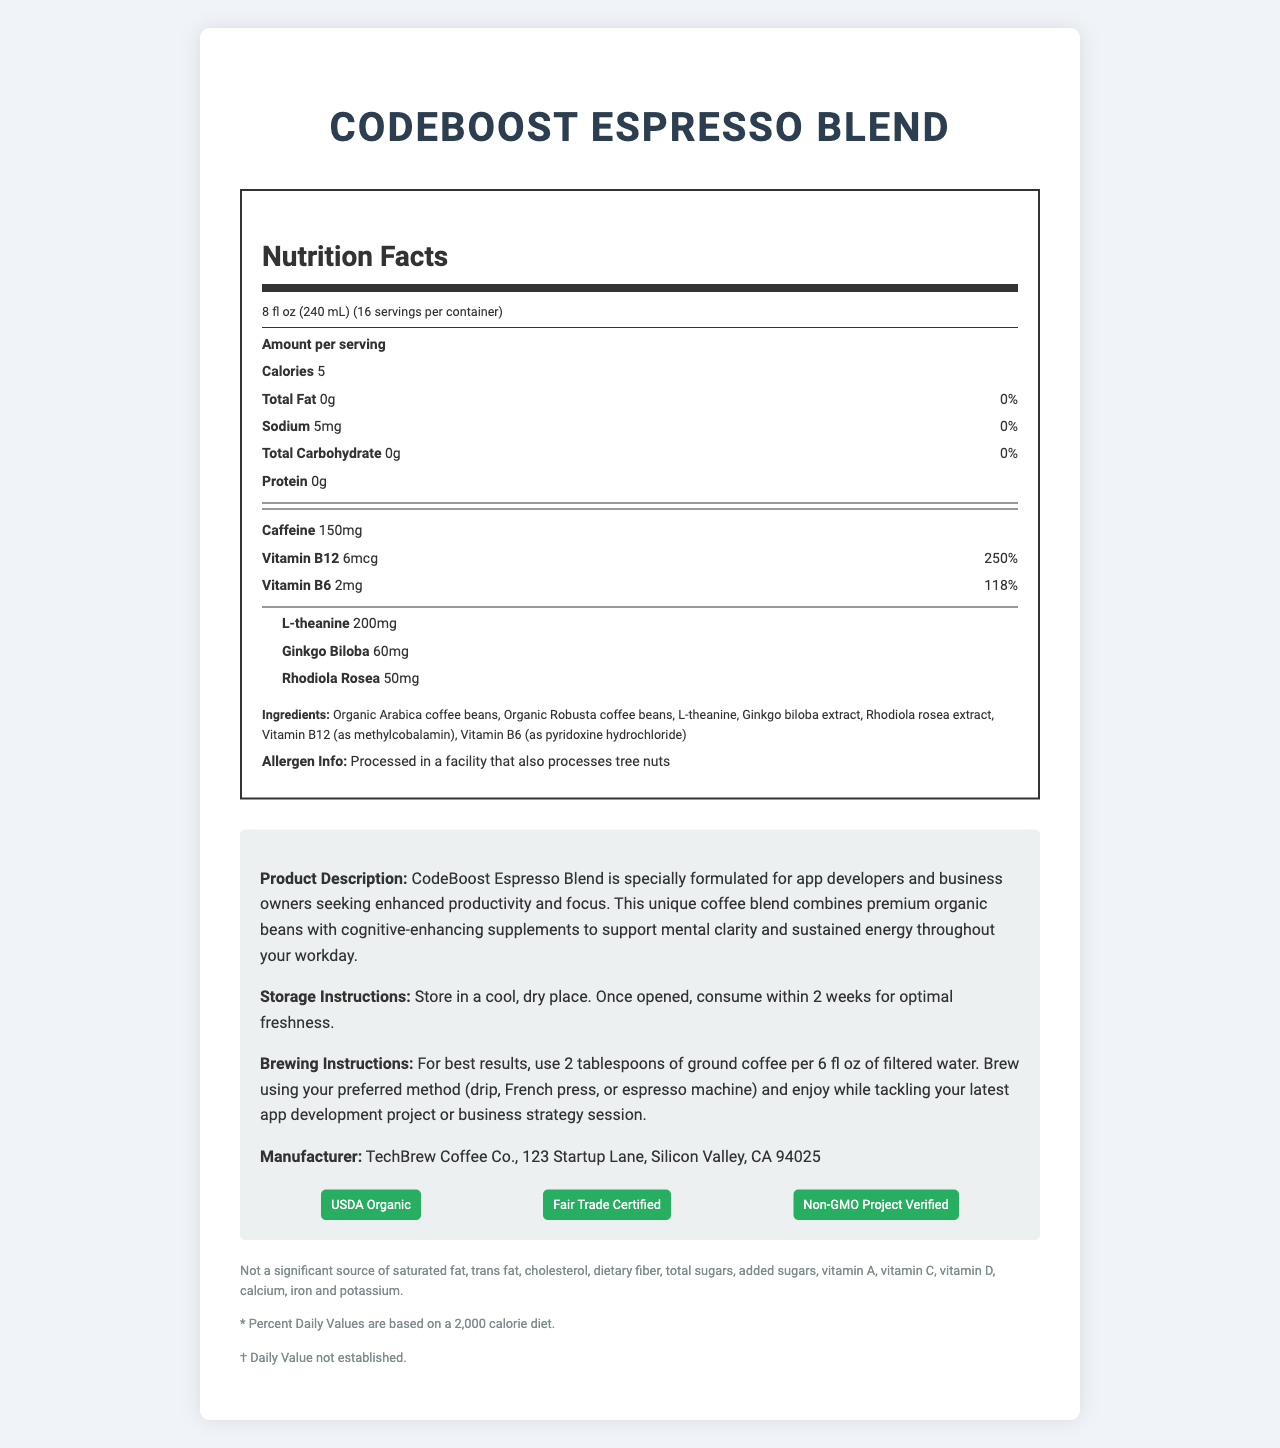what is the serving size for CodeBoost Espresso Blend? The serving size is mentioned at the top of the nutrition label as "8 fl oz (240 mL)".
Answer: 8 fl oz (240 mL) how many servings are there per container of CodeBoost Espresso Blend? The number of servings per container is listed as "16" in the serving information section of the document.
Answer: 16 how many calories are in one serving of CodeBoost Espresso Blend? The number of calories per serving is clearly stated as "Calories 5" in the nutrition label.
Answer: 5 how much caffeine does one serving of CodeBoost Espresso Blend contain? The amount of caffeine per serving is listed in the vitamins section as "Caffeine 150mg".
Answer: 150mg what are the main ingredients of CodeBoost Espresso Blend? The main ingredients are listed in the ingredients section of the document.
Answer: Organic Arabica coffee beans, Organic Robusta coffee beans, L-theanine, Ginkgo biloba extract, Rhodiola rosea extract, Vitamin B12 (as methylcobalamin), Vitamin B6 (as pyridoxine hydrochloride) which vitamin in CodeBoost Espresso Blend has the highest daily value percentage? Vitamin B12 has a daily value of 250%, which is the highest compared to other vitamins listed.
Answer: Vitamin B12 in which type of facility is CodeBoost Espresso Blend processed? A. Gluten-free B. Gluten and dairy-free C. Tree nut processing facility D. Dairy-free The allergen info states that the product is "Processed in a facility that also processes tree nuts".
Answer: C. Tree nut processing facility how should you store CodeBoost Espresso Blend once opened? A. In the refrigerator B. In a cool, dry place C. In a humid place D. In an airtight container The storage instructions specify to "Store in a cool, dry place."
Answer: B. In a cool, dry place how many tablespoons of ground coffee should you use per 6 fl oz of filtered water? The brewing instructions recommend using "2 tablespoons of ground coffee per 6 fl oz of filtered water."
Answer: 2 tablespoons does CodeBoost Espresso Blend contain any significant amount of dietary fiber or total sugars? The disclaimers state that it is not a significant source of dietary fiber, total sugars, among other nutrients.
Answer: No is CodeBoost Espresso Blend non-GMO certified? One of the certifications listed is "Non-GMO Project Verified."
Answer: Yes what is the primary purpose of CodeBoost Espresso Blend described in the product description? The product description mentions that the blend is formulated for "enhanced productivity and focus."
Answer: Enhanced productivity and focus list all certifications that CodeBoost Espresso Blend holds. The certifications section lists these three certifications.
Answer: USDA Organic, Fair Trade Certified, Non-GMO Project Verified does CodeBoost Espresso Blend have any cholesterol or saturated fat? The disclaimers mention that it is not a significant source of cholesterol or saturated fat.
Answer: No how long should you consume CodeBoost Espresso Blend after opening for optimal freshness? The storage instructions state that once opened, it should be consumed within 2 weeks for optimal freshness.
Answer: Within 2 weeks describe the main idea of the document. The entire document outlines the features and benefits of CodeBoost Espresso Blend. It includes serving size, nutritional values, ingredients, storage and brewing instructions, allergen and certification information, and a product description geared towards productivity and focus enhancement.
Answer: The document provides nutritional and product information about CodeBoost Espresso Blend, which is a specialty coffee designed to boost productivity and focus. It details the ingredients, nutritional content, certifications, and usage instructions. how does CodeBoost Espresso Blend enhance mental clarity and sustained energy? The document mentions that the blend supports mental clarity and sustained energy but does not provide specific details or studies explaining how it achieves this.
Answer: Not enough information does CodeBoost Espresso Blend contain any Vitamin D? The disclaimers section explicitly mentions it is not a significant source of Vitamin D.
Answer: No 